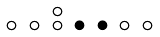<formula> <loc_0><loc_0><loc_500><loc_500>\begin{smallmatrix} & & \circ \\ \circ & \circ & \circ & \bullet & \bullet & \circ & \circ & \\ \end{smallmatrix}</formula> 